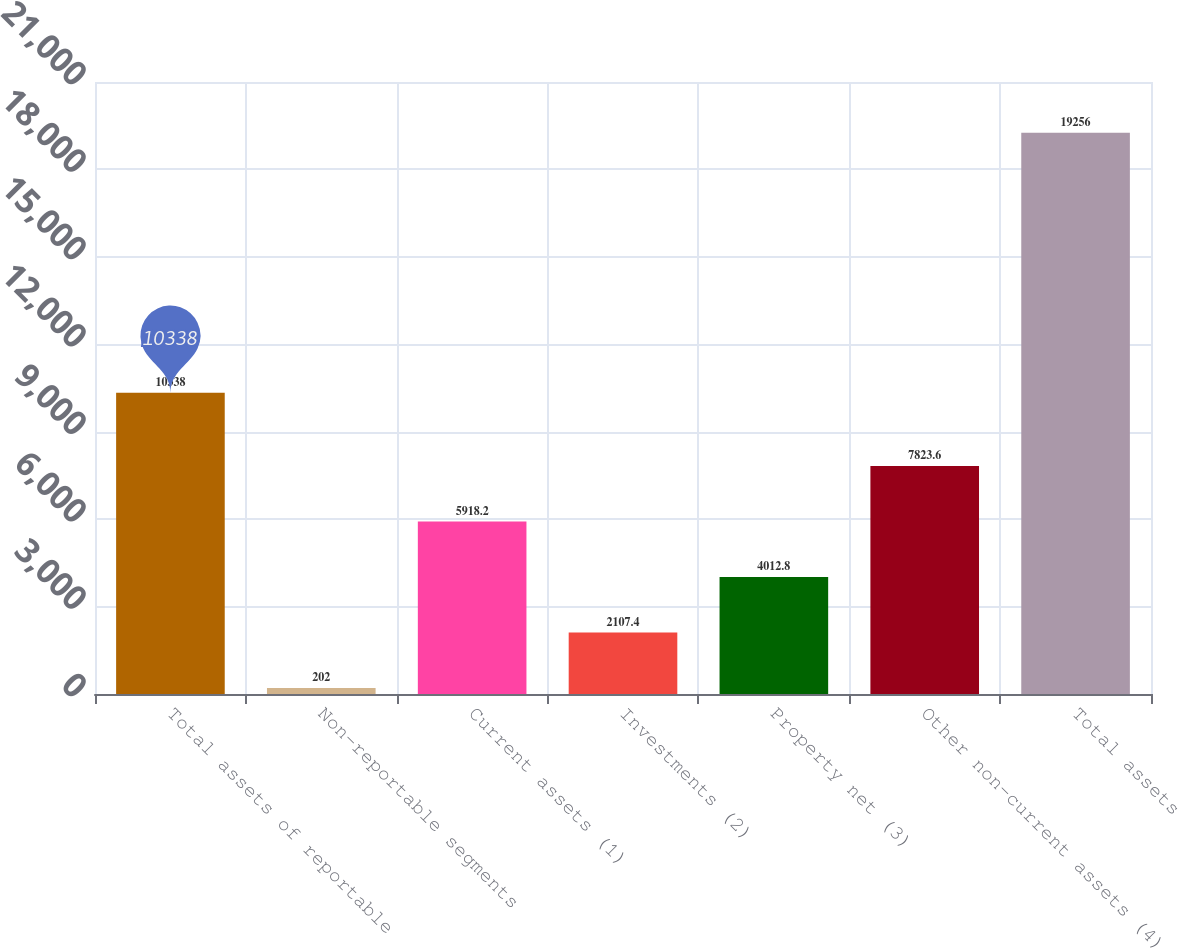Convert chart to OTSL. <chart><loc_0><loc_0><loc_500><loc_500><bar_chart><fcel>Total assets of reportable<fcel>Non-reportable segments<fcel>Current assets (1)<fcel>Investments (2)<fcel>Property net (3)<fcel>Other non-current assets (4)<fcel>Total assets<nl><fcel>10338<fcel>202<fcel>5918.2<fcel>2107.4<fcel>4012.8<fcel>7823.6<fcel>19256<nl></chart> 